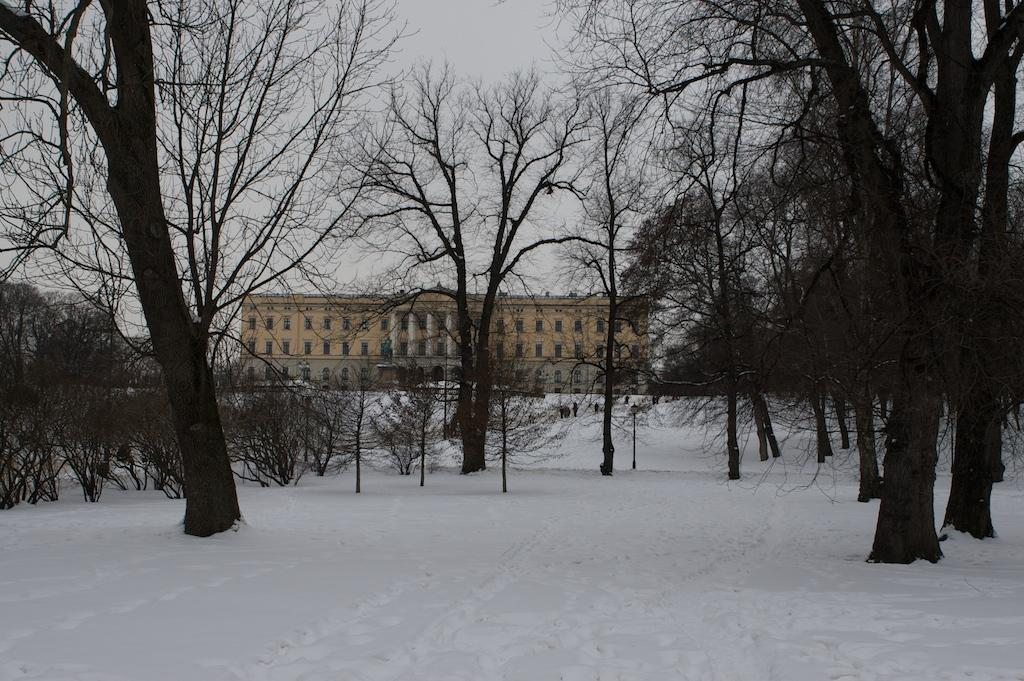What type of vegetation can be seen in the image? There are many trees and plants in the image. What is the weather like in the image? There is snow visible in the image, indicating a cold or wintry environment. What can be seen in the background of the image? There is a building in the background of the image. What is visible at the top of the image? The sky is visible at the top of the image, and clouds are present in the sky. How many beans are present in the image? There are no beans visible in the image. What type of leg can be seen supporting the building in the image? There is no leg supporting the building in the image; it is a solid structure. 